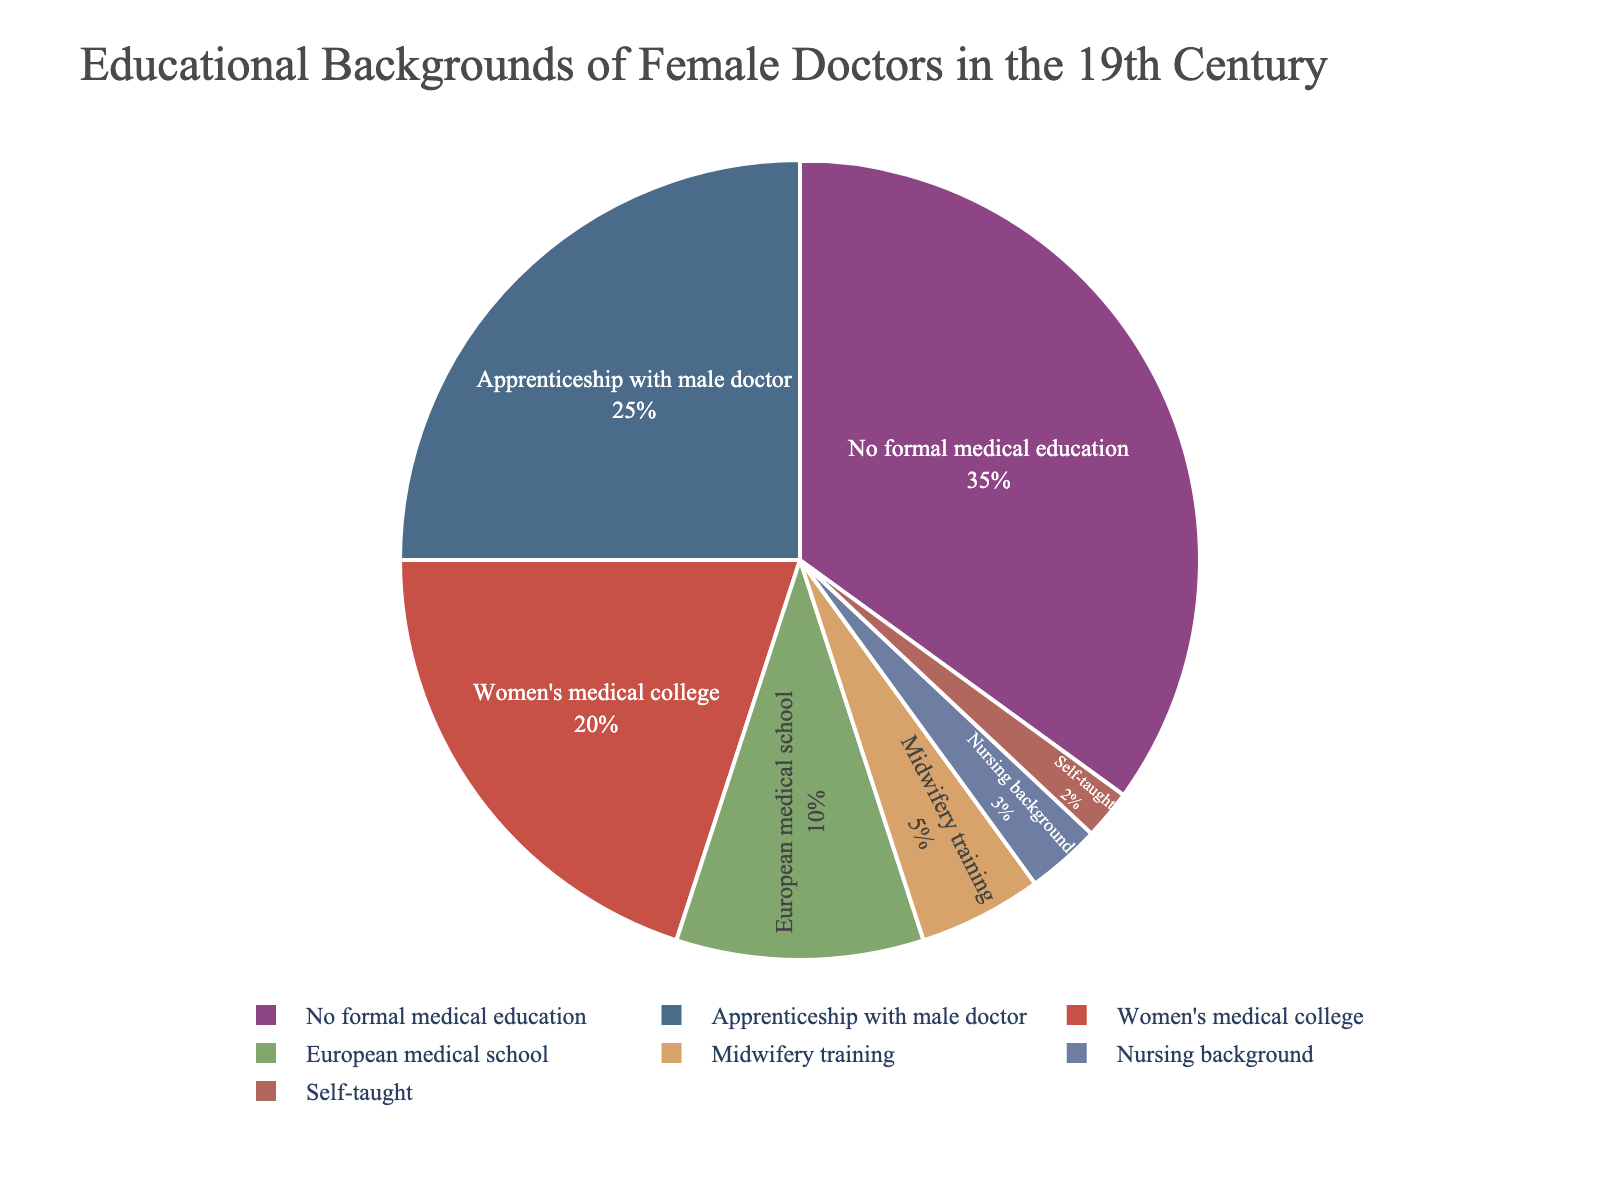Which educational background for female doctors holds the highest percentage in the pie chart? The largest segment in the pie chart represents "No formal medical education".
Answer: No formal medical education What is the combined percentage of female doctors who had no formal medical education and those who completed an apprenticeship with a male doctor? The percentage for "No formal medical education" is 35%, and for "Apprenticeship with male doctor", it is 25%. Adding these together: 35 + 25 = 60.
Answer: 60% Which educational background category has the smallest representation in the chart? The smallest segment in the pie chart is "Self-taught" with 2%.
Answer: Self-taught How much more common was attending a women's medical college than having a nursing background among female doctors? Women's medical college has a segment of 20%, while the Nursing background has 3%. Subtracting these: 20 - 3 = 17.
Answer: 17% Are there more female doctors with midwifery training or European medical school education? The segment for "Midwifery training" is 5%, while "European medical school" is 10%. "European medical school" has a larger percentage.
Answer: European medical school What is the total percentage of female doctors who had formal education (combining women's medical college, European medical school, and midwifery training)? The percentages for formal education categories are: women's medical college (20%), European medical school (10%), and midwifery training (5%). Summing these: 20 + 10 + 5 = 35.
Answer: 35% Compare the total percentage of female doctors with some form of formal medical education (including women's medical college, European medical school, and midwifery training) to those without formal medical education (including no formal medical education, apprenticeship with male doctor, nursing background, and self-taught). Which group is larger and by how much? Formal education categories sum up to 35% (20% + 10% + 5%). Non-formal education categories add to 65% (35% + 25% + 3% + 2%). Subtracting these: 65 - 35 = 30. Non-formal education group is larger by 30%.
Answer: Non-formal education by 30% 